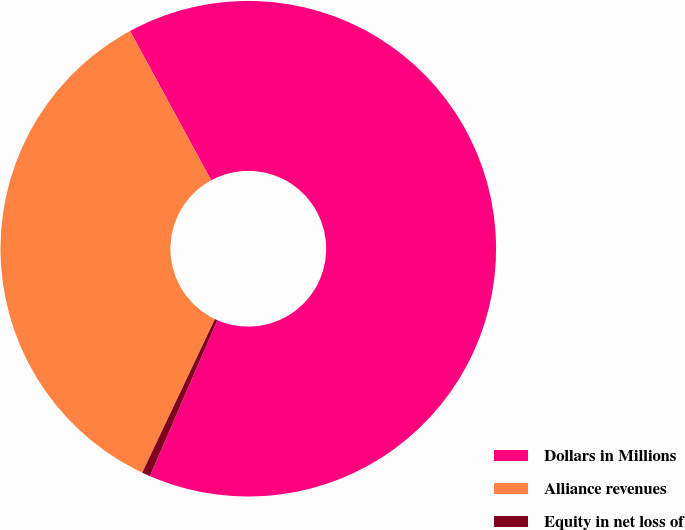<chart> <loc_0><loc_0><loc_500><loc_500><pie_chart><fcel>Dollars in Millions<fcel>Alliance revenues<fcel>Equity in net loss of<nl><fcel>64.42%<fcel>35.04%<fcel>0.54%<nl></chart> 